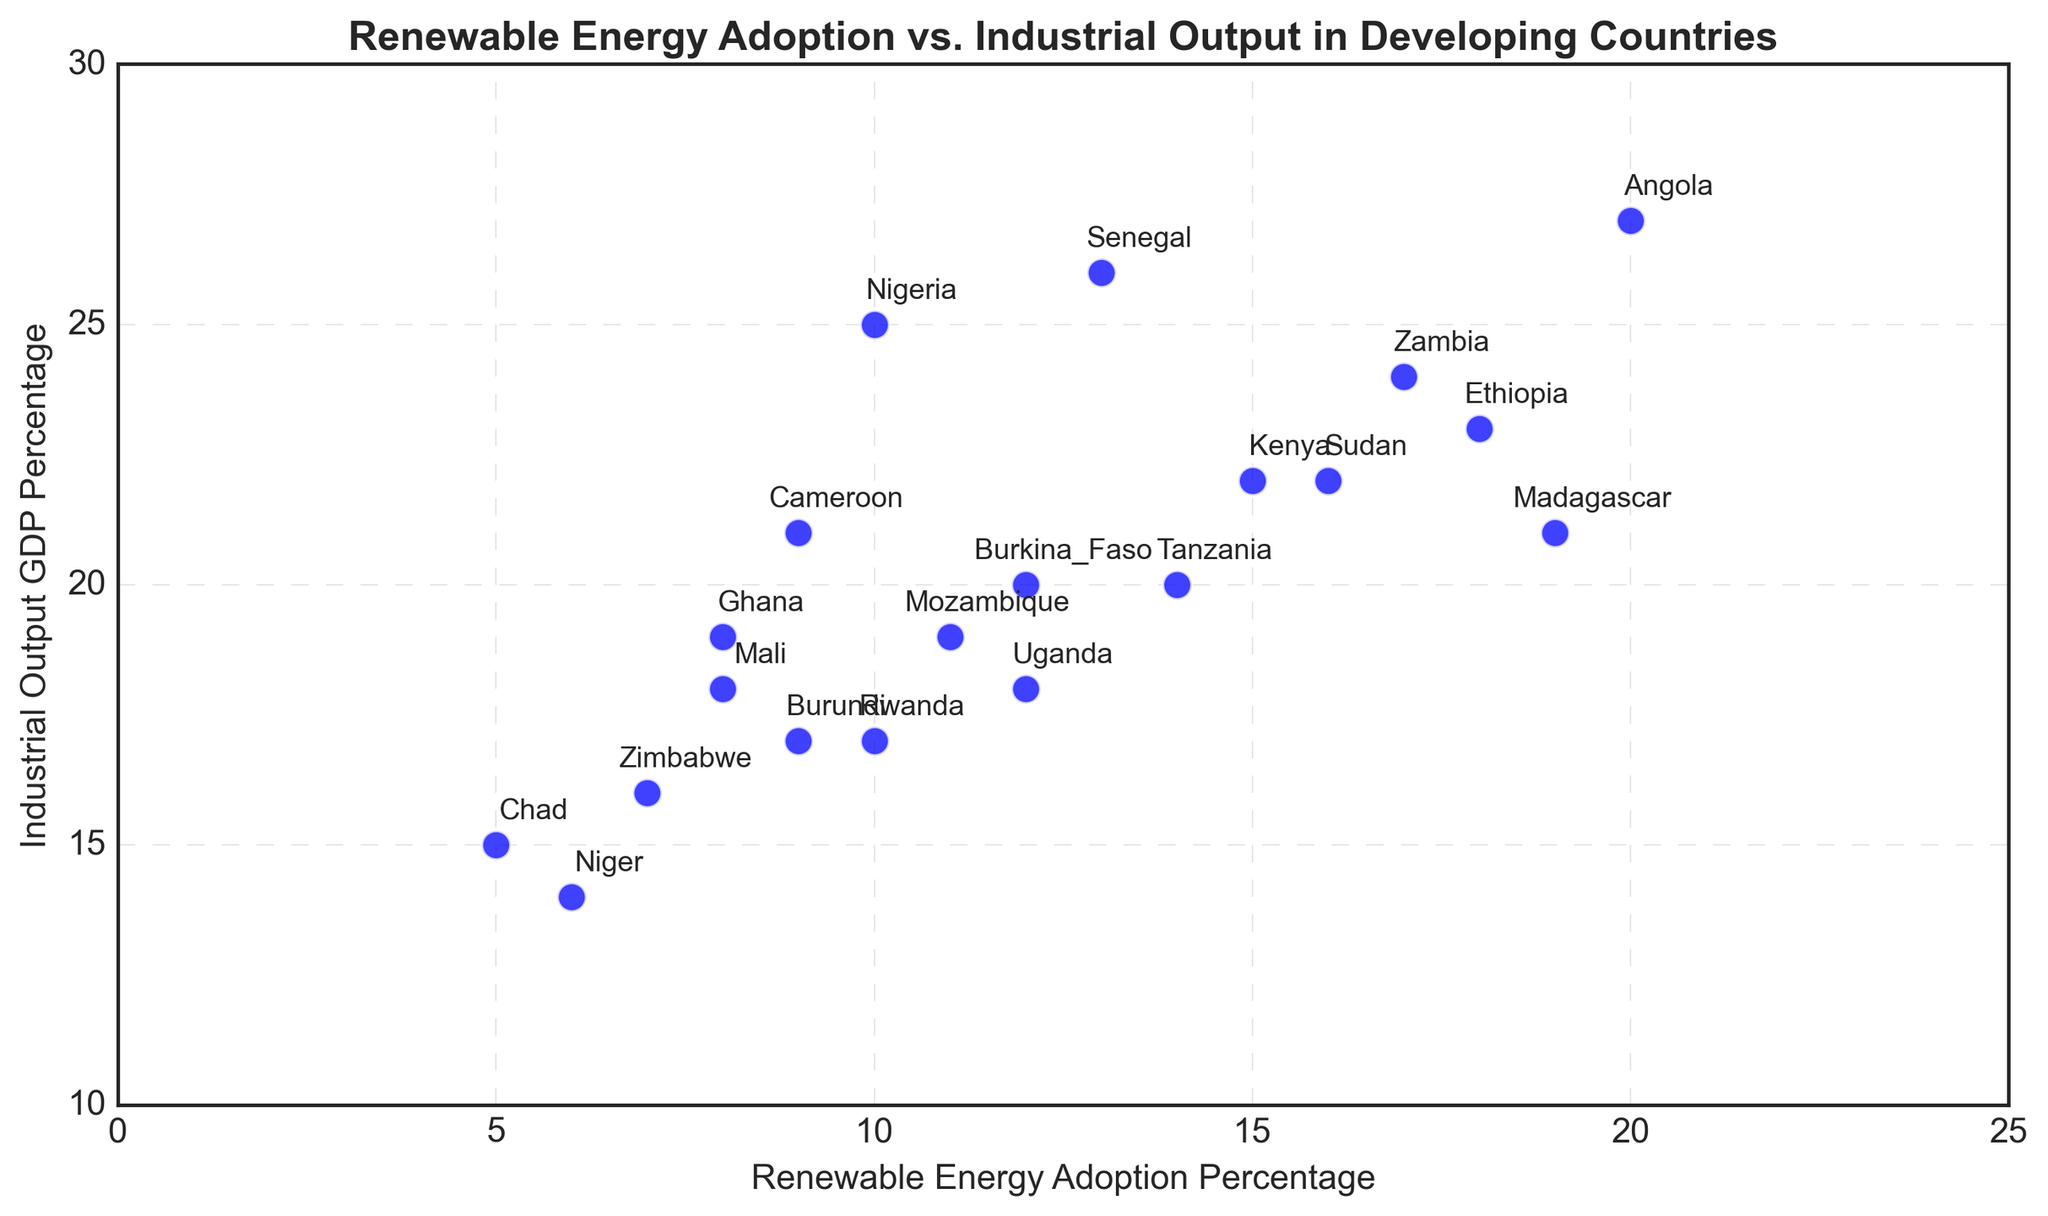Which country has the highest renewable energy adoption percentage? Angola has the highest renewable energy adoption percentage since it is plotted the farthest along the x-axis, at 20% renewable energy adoption.
Answer: Angola Which country contributes the least to industrial output as a percentage of GDP? Niger contributes the least to industrial output as a percentage of GDP because it is plotted the lowest on the y-axis at 14%.
Answer: Niger What is the average renewable energy adoption percentage for countries with an industrial output GDP percentage above 20? Countries above 20% industrial output GDP are Nigeria, Kenya, Ethiopia, Zambia, Senegal, and Angola. Their renewable energy adoption percentages are 10, 15, 18, 17, 13, and 20. The average is (10+15+18+17+13+20) / 6 = 93 / 6 = 15.5.
Answer: 15.5 Which country has a higher industrial output GDP percentage: Uganda or Rwanda? Uganda has an industrial output GDP percentage of 18%, while Rwanda has 17%. Industrial output GDP is higher for Uganda.
Answer: Uganda Which two countries have the closest renewable energy adoption percentages but different industrial outputs? Rwanda and Cameroon both have renewable energy adoption percentages of 9% but different industrial outputs of 17% and 21%, respectively.
Answer: Rwanda and Cameroon What is the range of industrial output GDP percentages among all countries? The maximum industrial output GDP percentage is 27% (Angola), and the minimum is 14% (Niger). So, the range is 27 - 14 = 13.
Answer: 13 How many countries have a renewable energy adoption percentage less than 10? Countries with renewable energy adoption percentages less than 10 are Ghana, Zimbabwe, Cameroon, Chad, and Niger. There are 5 countries in total.
Answer: 5 Which country has a higher renewable energy adoption percentage: Sudan or Tanzania? Sudan has a renewable energy adoption percentage of 16%, while Tanzania has 14%. Renewable energy adoption is higher in Sudan.
Answer: Sudan What is the median renewable energy adoption percentage for the countries listed? The renewable energy adoption percentages, in ascending order, are 5, 6, 7, 8, 8, 9, 9, 10, 10, 11, 12, 12, 13, 14, 15, 16, 17, 18, 19, 20. With 20 data points, the median is the average of the 10th and 11th values, which are 11 and 12. Thus, (11+12)/2 = 11.5.
Answer: 11.5 Which countries have an industrial output GDP percentage above 25%? Countries with industrial output GDP percentages above 25% are Senegal (26%) and Angola (27%).
Answer: Senegal and Angola 